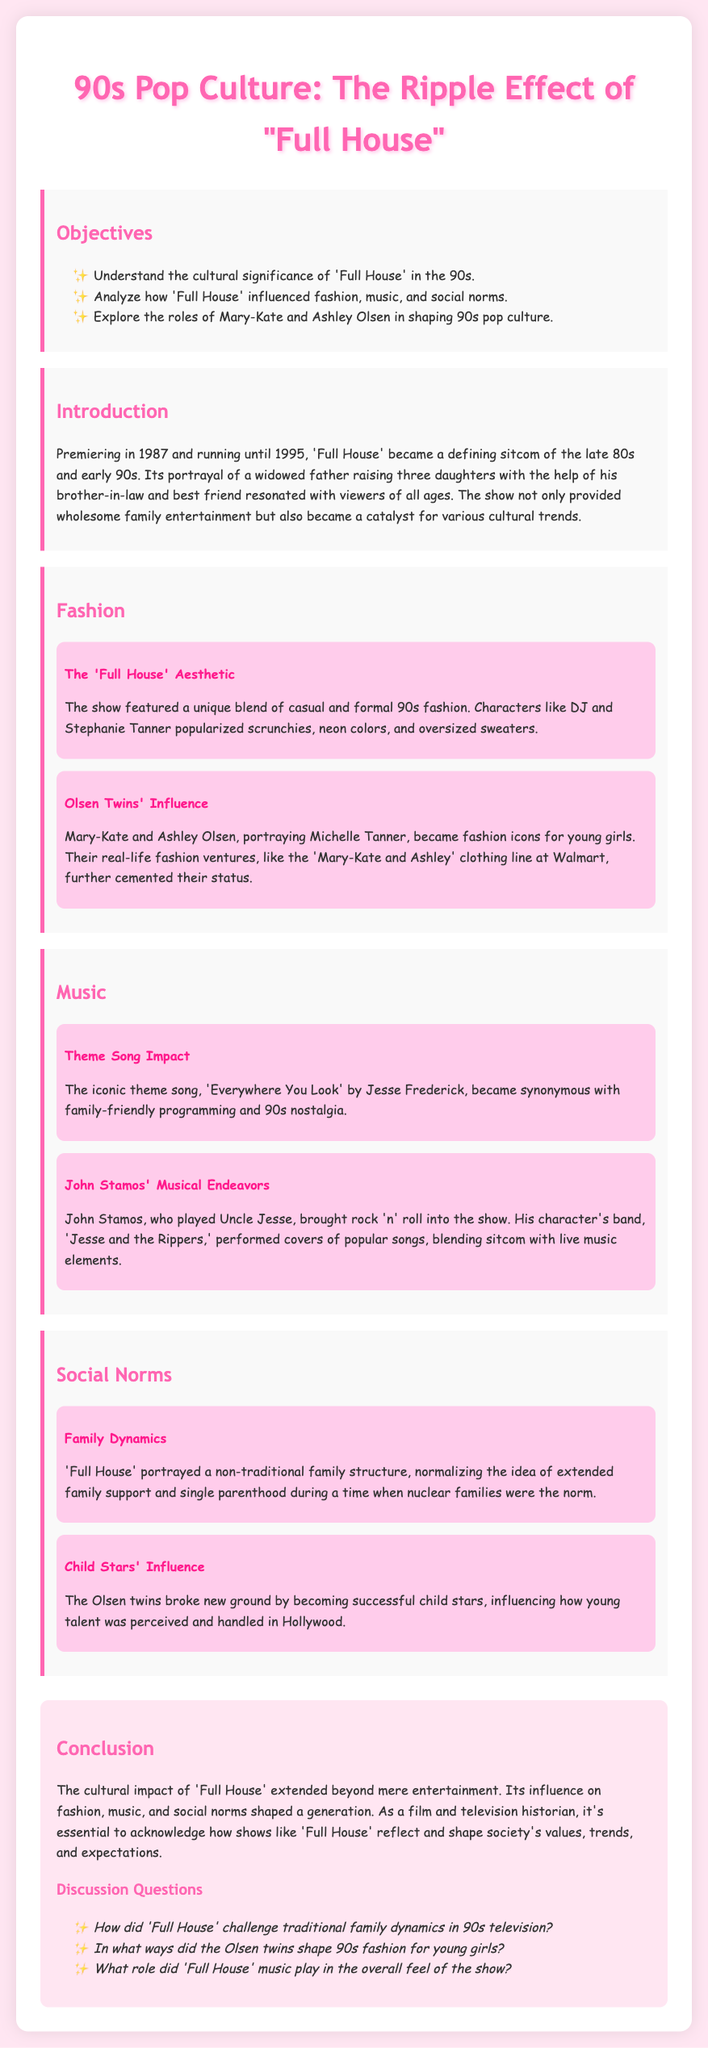What is the title of the lesson plan? The title of the lesson plan is found in the document's header, which states the focus of the lesson.
Answer: 90s Pop Culture: The Ripple Effect of "Full House" What year did 'Full House' premiere? The document specifies the premiere year of 'Full House' in the introduction section.
Answer: 1987 Who performed the theme song for 'Full House'? The document identifies the artist responsible for the show's iconic theme song in the music section.
Answer: Jesse Frederick What fashion item did DJ and Stephanie Tanner popularize? The document mentions a specific fashion item that gained popularity through the characters in the fashion section.
Answer: Scrunchies What non-traditional family structure did 'Full House' portray? This question requires understanding of how the show depicted family dynamics according to the social norms section.
Answer: Extended family support How did the Olsen twins influence young girls? The document explains the role of the Olsen twins in shaping fashion trends for a target audience in the fashion section.
Answer: Fashion icons What was the name of Uncle Jesse's band? The name of Uncle Jesse's band is provided in the music section of the document.
Answer: Jesse and the Rippers How long did 'Full House' run? The document mentions the duration of the show's airing in the introduction.
Answer: 8 years What role did 'Full House' music play in the show's overall feel? This question requires reasoning about the significance of the music based on information in the document.
Answer: Enhanced nostalgia 